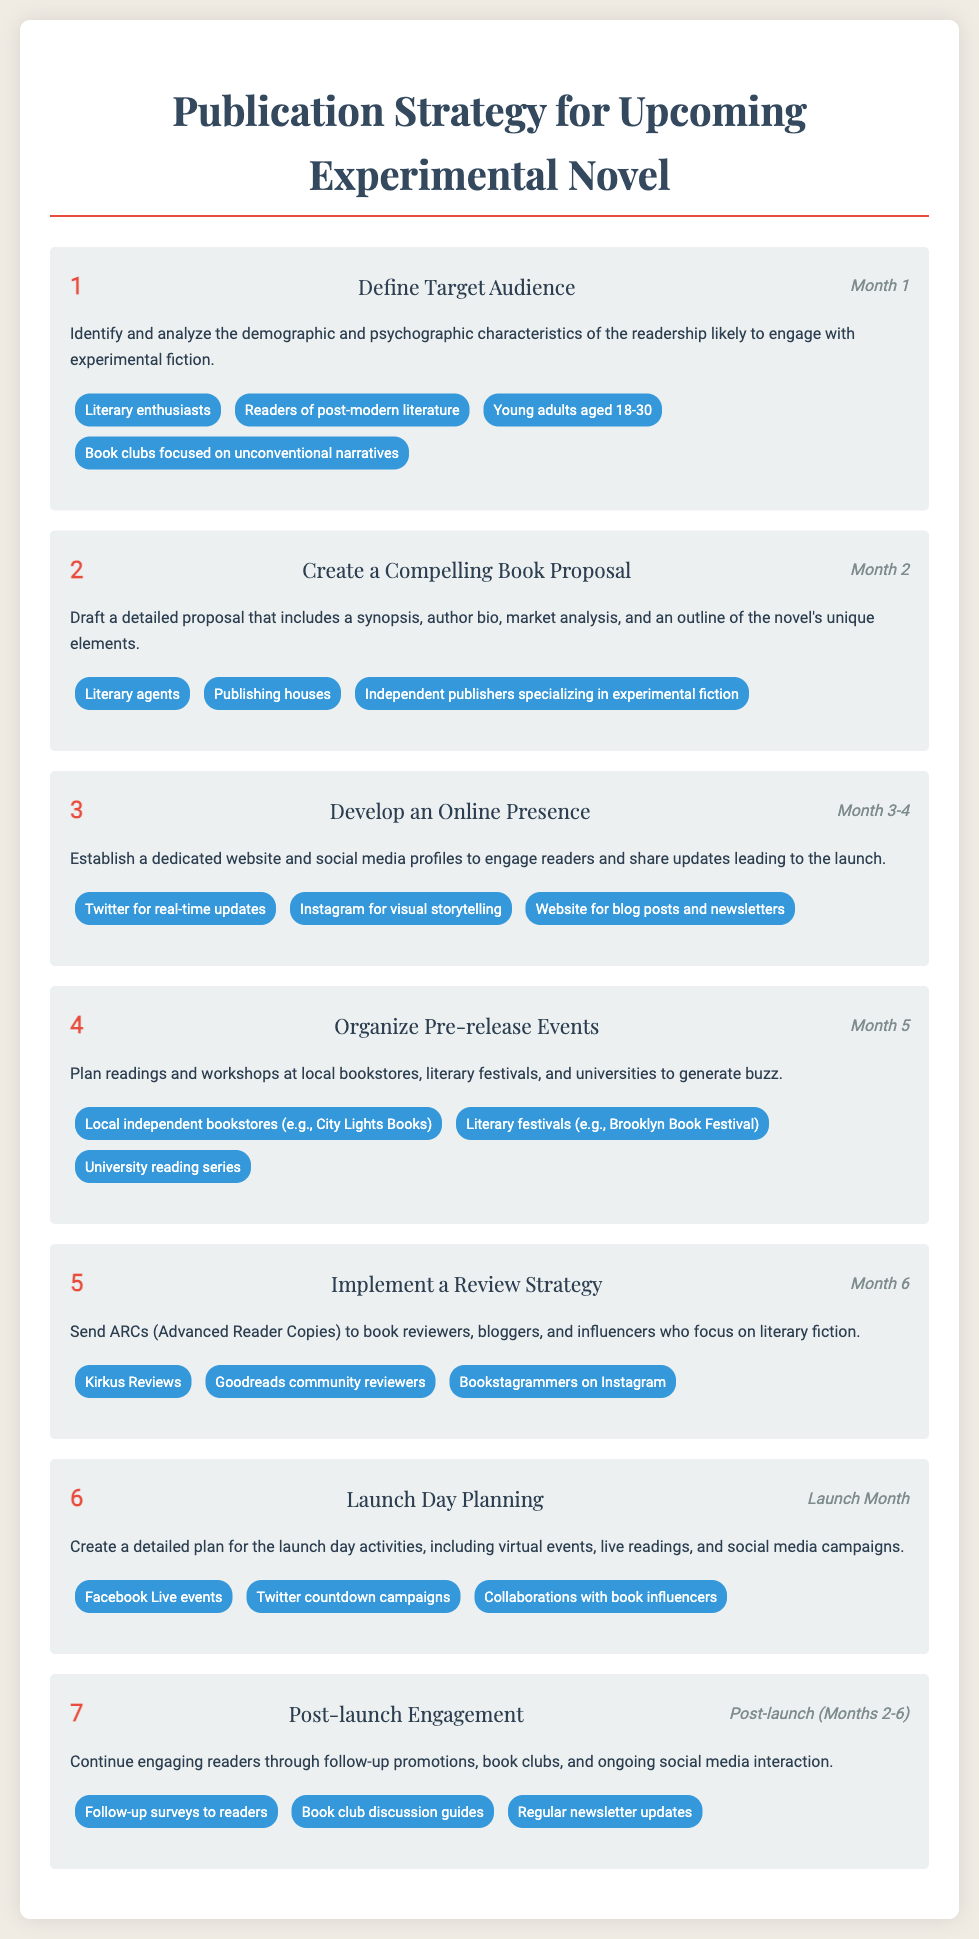What is the title of the document? The title of the document is presented prominently at the top and summarizes its main focus.
Answer: Publication Strategy for Upcoming Experimental Novel How many steps are outlined in the publication strategy? The number of steps is indicated numerically in the document, each corresponding to a distinct stage of the strategy.
Answer: 7 What is the target audience identified in Step 1? The document specifies a list of groups likely to engage with experimental fiction under the first step.
Answer: Literary enthusiasts In which month should the online presence be developed? The timeline for developing the online presence is clearly marked in the document.
Answer: Month 3-4 What are ARCs mentioned in Step 5? The abbreviation ARCs stands for a specific type of promotional material discussed in the review strategy.
Answer: Advanced Reader Copies What is one activity listed for the launch day planning? The launch day involves a variety of activities, one of which is highlighted in the respective step.
Answer: Virtual events What should be continued after the book launch? The document emphasizes the importance of ongoing engagement with readers after the book is released.
Answer: Post-launch engagement 